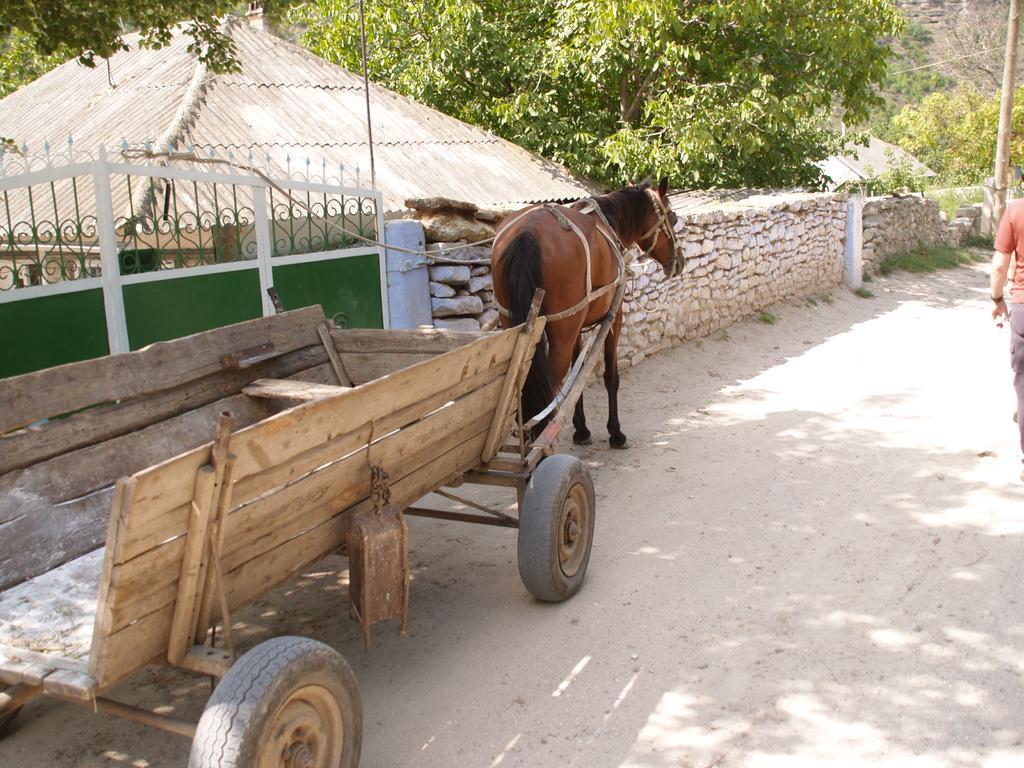Describe this image in one or two sentences. In this image, we can see a shelter. There is a horse cart in front of the wall. There is a tree at the top of the image. There is a person on the right side of the image. There is a pole in the top right of the image. 